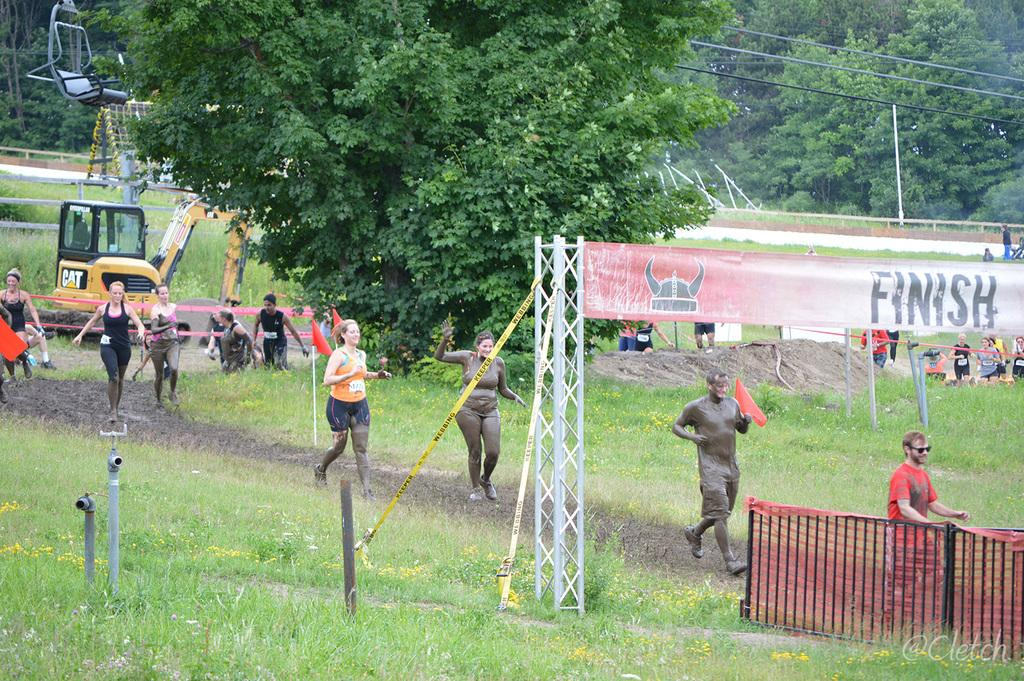<image>
Provide a brief description of the given image. Muddy people head toward the banner that says finish on it. 